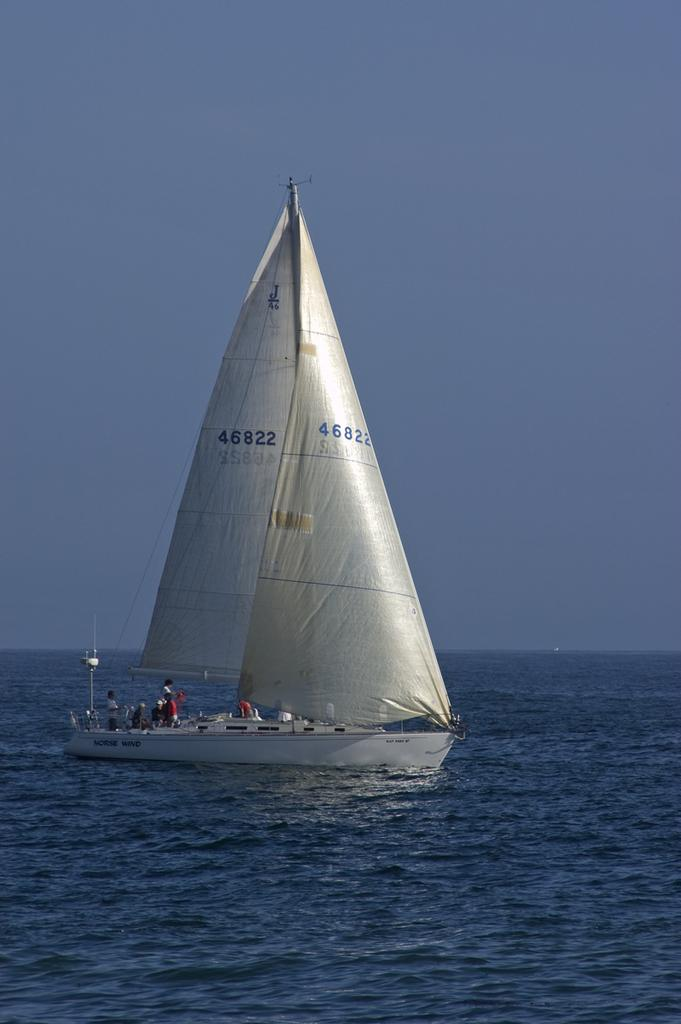What are the people doing in the image? The people are on a boat in the image. Where is the boat located? The boat is on the water. What can be seen in the background of the image? The sky is visible behind the boat. What type of pear is being used as a rudder for the boat in the image? There is no pear present in the image, and the boat does not have a pear as a rudder. 